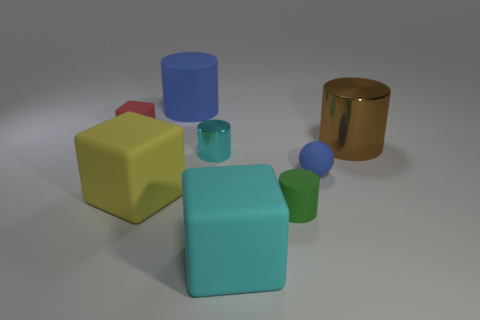Add 1 tiny yellow metallic balls. How many objects exist? 9 Subtract all spheres. How many objects are left? 7 Add 2 small red blocks. How many small red blocks exist? 3 Subtract 1 yellow blocks. How many objects are left? 7 Subtract all big rubber cylinders. Subtract all tiny green rubber cylinders. How many objects are left? 6 Add 2 large cylinders. How many large cylinders are left? 4 